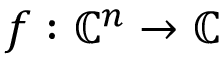Convert formula to latex. <formula><loc_0><loc_0><loc_500><loc_500>f \colon \mathbb { C } ^ { n } \to \mathbb { C }</formula> 